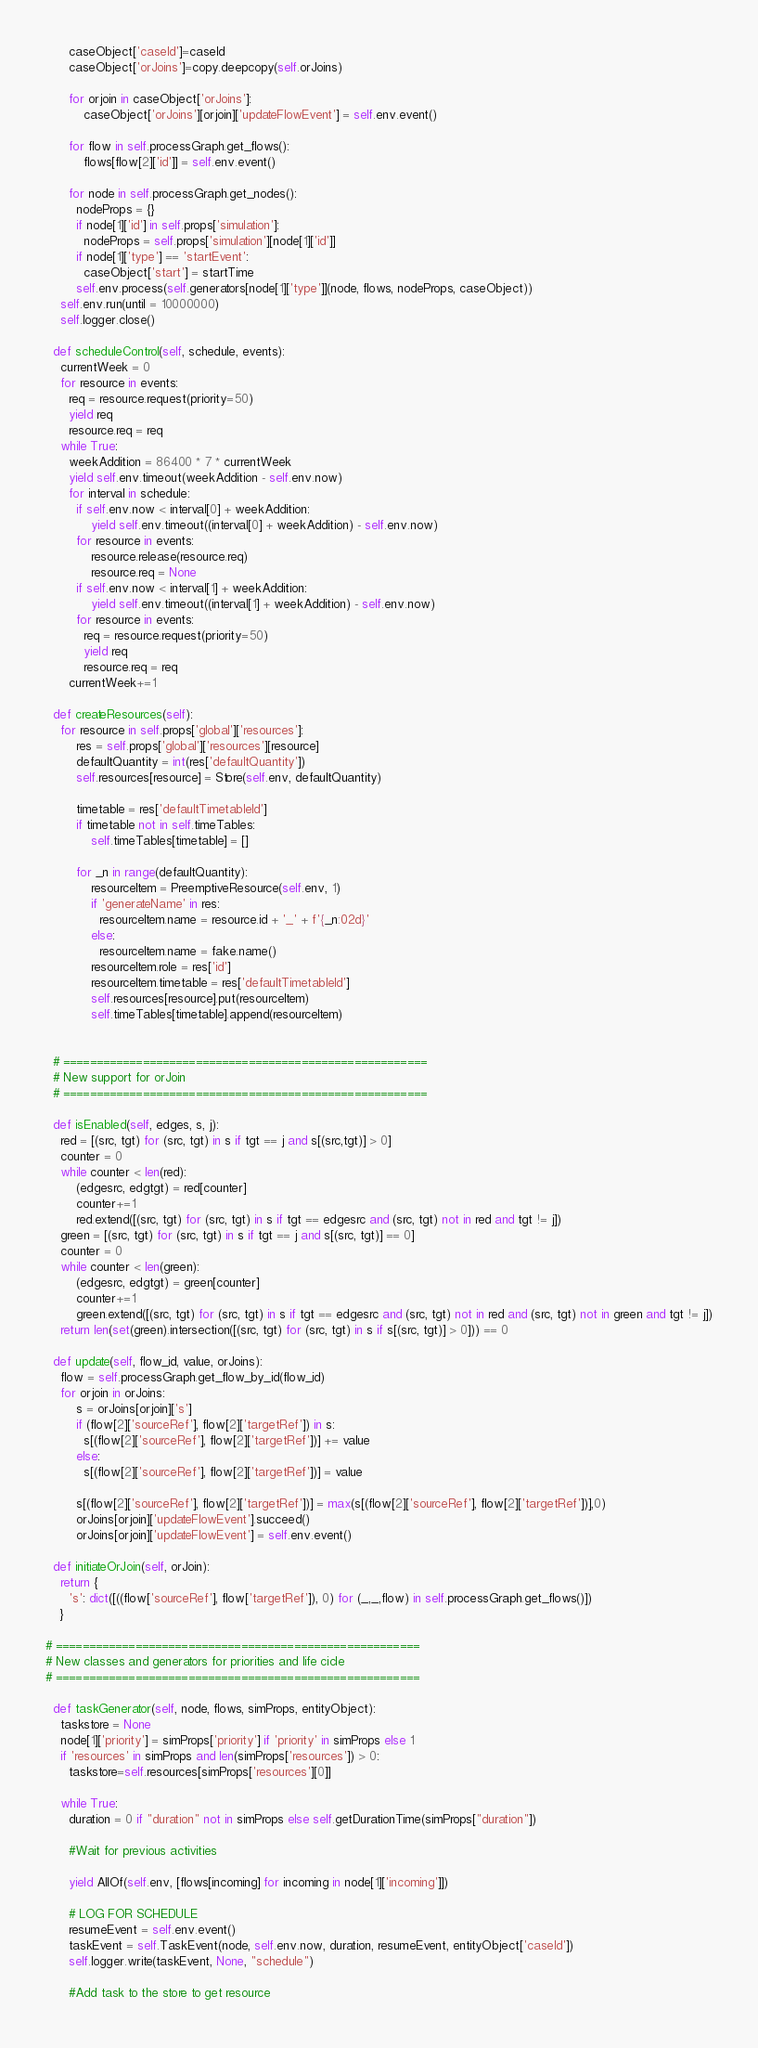<code> <loc_0><loc_0><loc_500><loc_500><_Python_>      caseObject['caseId']=caseId
      caseObject['orJoins']=copy.deepcopy(self.orJoins)

      for orjoin in caseObject['orJoins']:
          caseObject['orJoins'][orjoin]['updateFlowEvent'] = self.env.event()

      for flow in self.processGraph.get_flows():
          flows[flow[2]['id']] = self.env.event()

      for node in self.processGraph.get_nodes():
        nodeProps = {}
        if node[1]['id'] in self.props['simulation']:
          nodeProps = self.props['simulation'][node[1]['id']]
        if node[1]['type'] == 'startEvent':
          caseObject['start'] = startTime
        self.env.process(self.generators[node[1]['type']](node, flows, nodeProps, caseObject))
    self.env.run(until = 10000000)
    self.logger.close()

  def scheduleControl(self, schedule, events):
    currentWeek = 0
    for resource in events:
      req = resource.request(priority=50)
      yield req
      resource.req = req
    while True: 
      weekAddition = 86400 * 7 * currentWeek
      yield self.env.timeout(weekAddition - self.env.now)
      for interval in schedule:
        if self.env.now < interval[0] + weekAddition:
            yield self.env.timeout((interval[0] + weekAddition) - self.env.now)
        for resource in events:
            resource.release(resource.req)
            resource.req = None
        if self.env.now < interval[1] + weekAddition:
            yield self.env.timeout((interval[1] + weekAddition) - self.env.now)
        for resource in events:
          req = resource.request(priority=50)
          yield req
          resource.req = req
      currentWeek+=1

  def createResources(self):
    for resource in self.props['global']['resources']:
        res = self.props['global']['resources'][resource]
        defaultQuantity = int(res['defaultQuantity'])
        self.resources[resource] = Store(self.env, defaultQuantity)

        timetable = res['defaultTimetableId']
        if timetable not in self.timeTables:
            self.timeTables[timetable] = []
            
        for _n in range(defaultQuantity):
            resourceItem = PreemptiveResource(self.env, 1) 
            if 'generateName' in res:
              resourceItem.name = resource.id + '_' + f'{_n:02d}'
            else:
              resourceItem.name = fake.name()
            resourceItem.role = res['id']
            resourceItem.timetable = res['defaultTimetableId']
            self.resources[resource].put(resourceItem)
            self.timeTables[timetable].append(resourceItem)


  # =======================================================
  # New support for orJoin
  # =======================================================

  def isEnabled(self, edges, s, j):
    red = [(src, tgt) for (src, tgt) in s if tgt == j and s[(src,tgt)] > 0]
    counter = 0
    while counter < len(red):
        (edgesrc, edgtgt) = red[counter]
        counter+=1
        red.extend([(src, tgt) for (src, tgt) in s if tgt == edgesrc and (src, tgt) not in red and tgt != j])
    green = [(src, tgt) for (src, tgt) in s if tgt == j and s[(src, tgt)] == 0]
    counter = 0
    while counter < len(green):
        (edgesrc, edgtgt) = green[counter]
        counter+=1
        green.extend([(src, tgt) for (src, tgt) in s if tgt == edgesrc and (src, tgt) not in red and (src, tgt) not in green and tgt != j])
    return len(set(green).intersection([(src, tgt) for (src, tgt) in s if s[(src, tgt)] > 0])) == 0
  
  def update(self, flow_id, value, orJoins):
    flow = self.processGraph.get_flow_by_id(flow_id)
    for orjoin in orJoins:
        s = orJoins[orjoin]['s']
        if (flow[2]['sourceRef'], flow[2]['targetRef']) in s:
          s[(flow[2]['sourceRef'], flow[2]['targetRef'])] += value
        else: 
          s[(flow[2]['sourceRef'], flow[2]['targetRef'])] = value

        s[(flow[2]['sourceRef'], flow[2]['targetRef'])] = max(s[(flow[2]['sourceRef'], flow[2]['targetRef'])],0)
        orJoins[orjoin]['updateFlowEvent'].succeed()
        orJoins[orjoin]['updateFlowEvent'] = self.env.event()

  def initiateOrJoin(self, orJoin):
    return {
      's': dict([((flow['sourceRef'], flow['targetRef']), 0) for (_,_,flow) in self.processGraph.get_flows()])
    }

# =======================================================
# New classes and generators for priorities and life cicle
# =======================================================

  def taskGenerator(self, node, flows, simProps, entityObject):
    taskstore = None
    node[1]['priority'] = simProps['priority'] if 'priority' in simProps else 1
    if 'resources' in simProps and len(simProps['resources']) > 0:
      taskstore=self.resources[simProps['resources'][0]]

    while True:
      duration = 0 if "duration" not in simProps else self.getDurationTime(simProps["duration"])
      
      #Wait for previous activities

      yield AllOf(self.env, [flows[incoming] for incoming in node[1]['incoming']])

      # LOG FOR SCHEDULE
      resumeEvent = self.env.event()
      taskEvent = self.TaskEvent(node, self.env.now, duration, resumeEvent, entityObject['caseId'])
      self.logger.write(taskEvent, None, "schedule")

      #Add task to the store to get resource</code> 